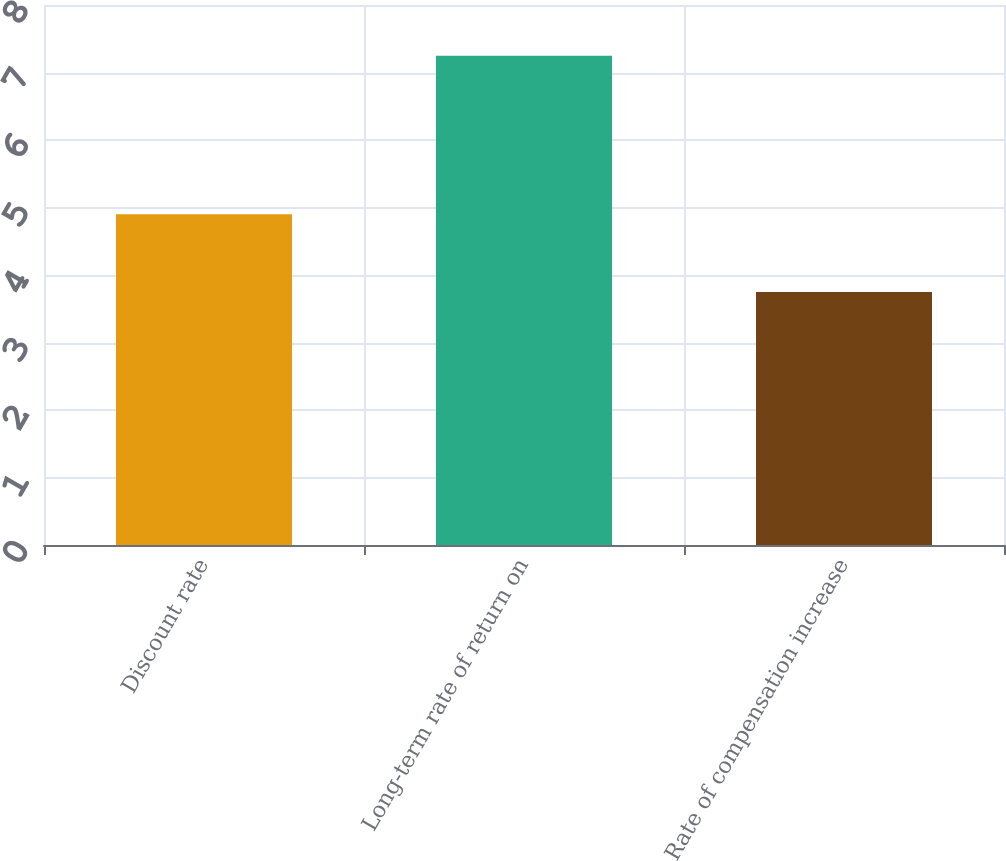Convert chart to OTSL. <chart><loc_0><loc_0><loc_500><loc_500><bar_chart><fcel>Discount rate<fcel>Long-term rate of return on<fcel>Rate of compensation increase<nl><fcel>4.9<fcel>7.25<fcel>3.75<nl></chart> 